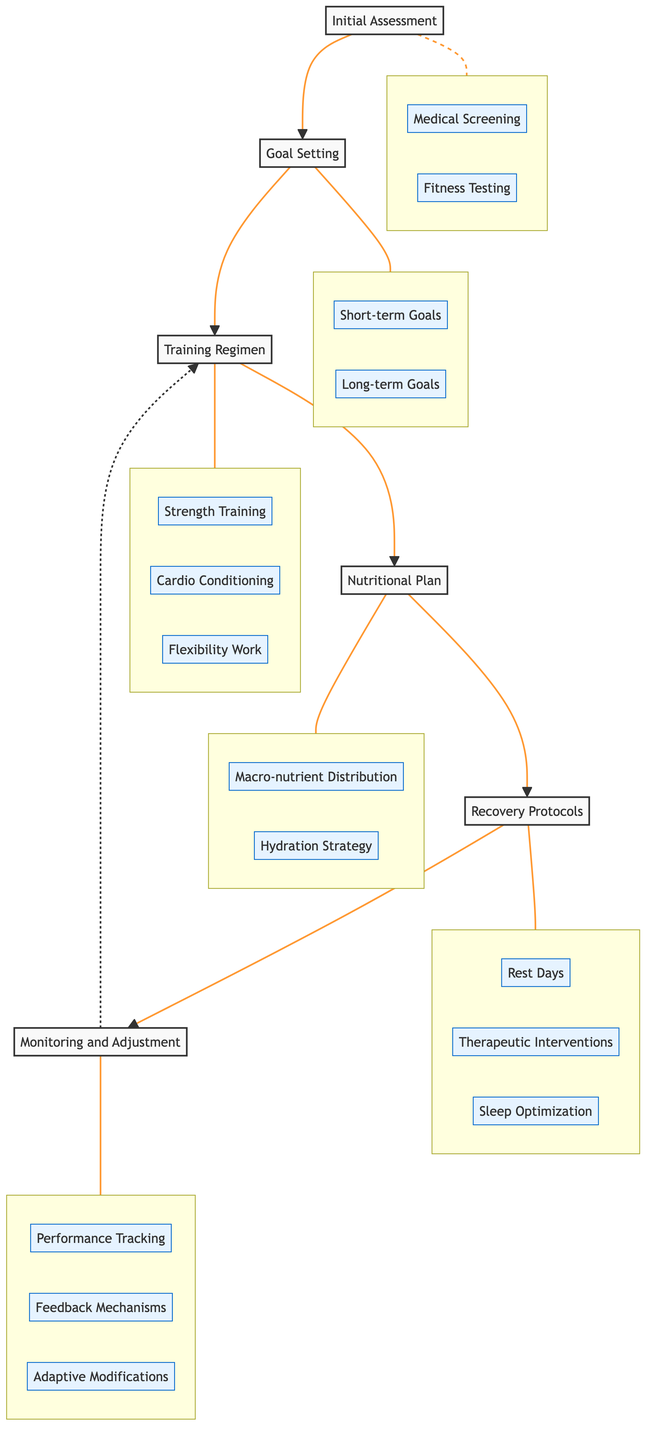What is the first step in the pathway? The first step in the pathway is "Initial Assessment," which is depicted as the starting node in the diagram.
Answer: Initial Assessment How many main elements are in the pathway? Counting the nodes in the diagram, there are six main elements that represent different stages in the pre-competition conditioning protocols.
Answer: 6 Which element comes after "Goal Setting"? Following the flow from "Goal Setting," the next element is "Training Regimen," indicating the sequential process in the conditioning pathway.
Answer: Training Regimen What are the components of "Nutritional Plan"? The components of the "Nutritional Plan" include "Macro-nutrient Distribution" and "Hydration Strategy," as shown in the subgraph connected to this element.
Answer: Macro-nutrient Distribution, Hydration Strategy What is the relationship between "Monitoring and Adjustment" and "Training Regimen"? The diagram shows a dashed line connecting "Monitoring and Adjustment" back to "Training Regimen," indicating that feedback from monitoring can lead to adjustments in the training program.
Answer: Feedback for adjustments How many components are there under "Recovery Protocols"? Under "Recovery Protocols," there are three components listed: "Rest Days," "Therapeutic Interventions," and "Sleep Optimization," summarizing the strategies for recovery.
Answer: 3 What is the last step in the pathway? The last step in the pathway is "Monitoring and Adjustment," which serves as the final node in the sequential process.
Answer: Monitoring and Adjustment What is the focus of the "Initial Assessment"? The focus of the "Initial Assessment" is on conducting a comprehensive evaluation of the athlete's current fitness levels, including various health checks and fitness tests.
Answer: Evaluation of fitness levels What type of strategies are included in "Recovery Protocols"? "Recovery Protocols" include strategies such as "Rest Days," "Therapeutic Interventions," and "Sleep Optimization," which are aimed at promoting recovery and preventing injuries.
Answer: Recovery and injury prevention strategies 